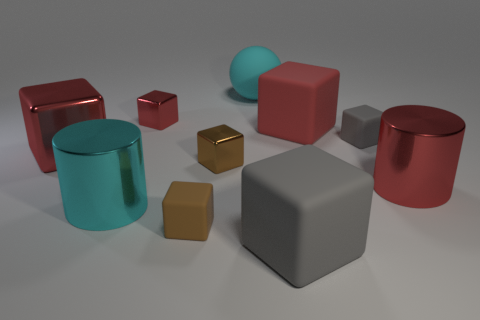How many red cubes must be subtracted to get 1 red cubes? 2 Subtract all small brown matte cubes. How many cubes are left? 6 Subtract 1 cylinders. How many cylinders are left? 1 Subtract all gray cubes. How many cubes are left? 5 Subtract all cylinders. How many objects are left? 8 Subtract all gray cubes. Subtract all big red things. How many objects are left? 5 Add 2 brown shiny things. How many brown shiny things are left? 3 Add 2 brown metal cubes. How many brown metal cubes exist? 3 Subtract 0 green cylinders. How many objects are left? 10 Subtract all cyan cylinders. Subtract all brown balls. How many cylinders are left? 1 